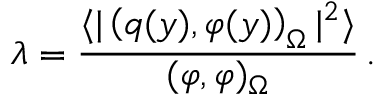<formula> <loc_0><loc_0><loc_500><loc_500>\lambda = \frac { \langle | \left ( q ( y ) , \varphi ( y ) \right ) _ { \Omega } | ^ { 2 } \rangle } { ( \varphi , \varphi ) _ { \Omega } } \, .</formula> 